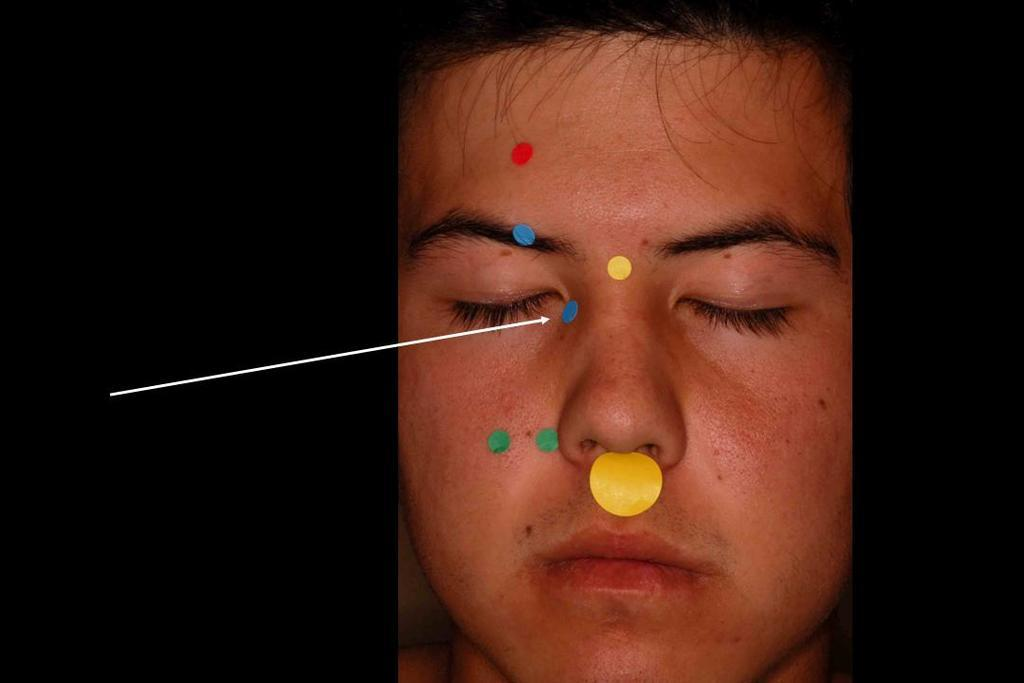What is the main subject of the image? There is a face of a person in the image. What is on the face in the image? There are stickers on the face. Where is the arrow located in the image? The arrow is on the left side of the image. How would you describe the overall appearance of the image? The sides of the image are dark. How many bursts of laughter can be heard coming from the office in the image? There is no office or indication of laughter in the image; it features a face with stickers and an arrow. 